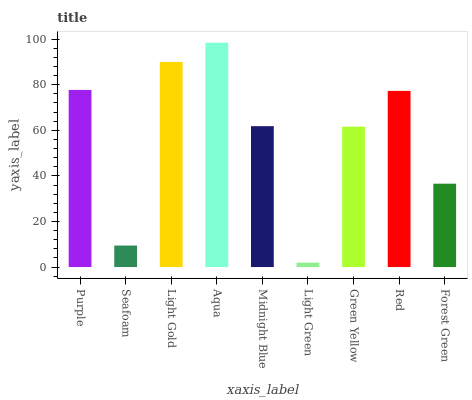Is Seafoam the minimum?
Answer yes or no. No. Is Seafoam the maximum?
Answer yes or no. No. Is Purple greater than Seafoam?
Answer yes or no. Yes. Is Seafoam less than Purple?
Answer yes or no. Yes. Is Seafoam greater than Purple?
Answer yes or no. No. Is Purple less than Seafoam?
Answer yes or no. No. Is Midnight Blue the high median?
Answer yes or no. Yes. Is Midnight Blue the low median?
Answer yes or no. Yes. Is Green Yellow the high median?
Answer yes or no. No. Is Seafoam the low median?
Answer yes or no. No. 